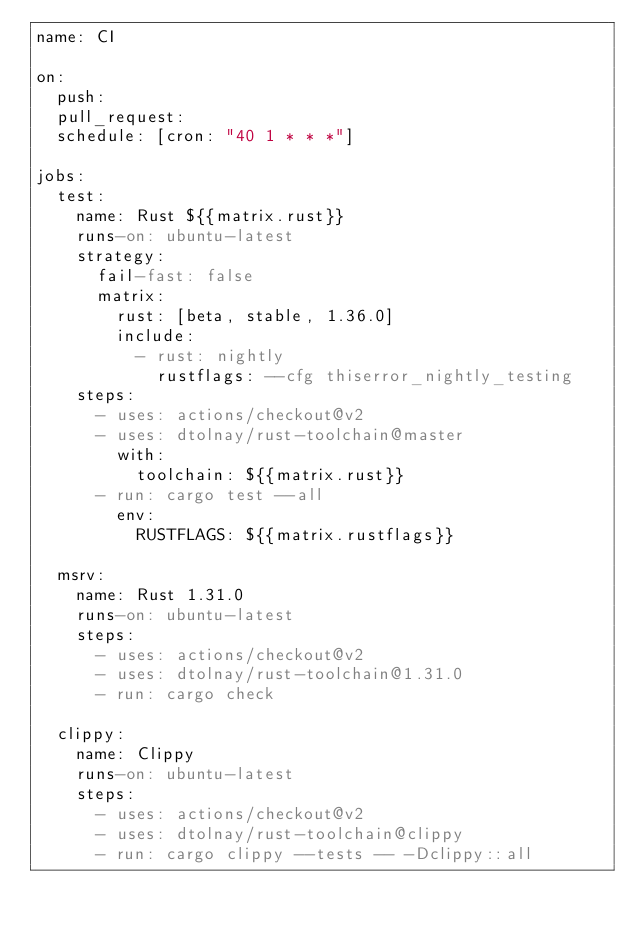<code> <loc_0><loc_0><loc_500><loc_500><_YAML_>name: CI

on:
  push:
  pull_request:
  schedule: [cron: "40 1 * * *"]

jobs:
  test:
    name: Rust ${{matrix.rust}}
    runs-on: ubuntu-latest
    strategy:
      fail-fast: false
      matrix:
        rust: [beta, stable, 1.36.0]
        include:
          - rust: nightly
            rustflags: --cfg thiserror_nightly_testing
    steps:
      - uses: actions/checkout@v2
      - uses: dtolnay/rust-toolchain@master
        with:
          toolchain: ${{matrix.rust}}
      - run: cargo test --all
        env:
          RUSTFLAGS: ${{matrix.rustflags}}

  msrv:
    name: Rust 1.31.0
    runs-on: ubuntu-latest
    steps:
      - uses: actions/checkout@v2
      - uses: dtolnay/rust-toolchain@1.31.0
      - run: cargo check

  clippy:
    name: Clippy
    runs-on: ubuntu-latest
    steps:
      - uses: actions/checkout@v2
      - uses: dtolnay/rust-toolchain@clippy
      - run: cargo clippy --tests -- -Dclippy::all
</code> 